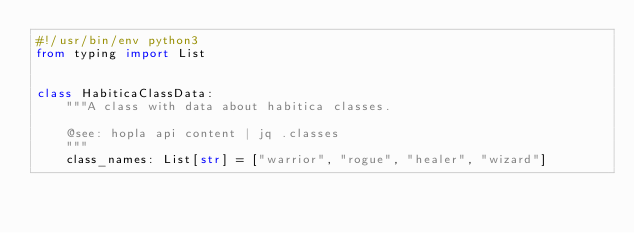Convert code to text. <code><loc_0><loc_0><loc_500><loc_500><_Python_>#!/usr/bin/env python3
from typing import List


class HabiticaClassData:
    """A class with data about habitica classes.

    @see: hopla api content | jq .classes
    """
    class_names: List[str] = ["warrior", "rogue", "healer", "wizard"]
</code> 